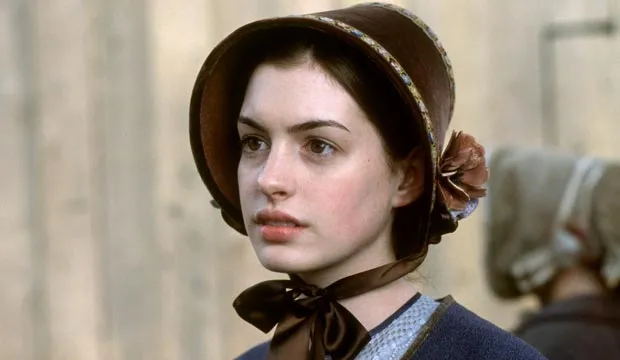What might this character be thinking about? This character could be pondering a multitude of things given her serious expression. She might be thinking about a lost love, reflecting on a pivotal moment in her life, or considering a difficult decision she has to make. The period costume suggests themes of duty, societal expectations, and possibly personal sacrifice. Describe a day in the life of this character. A day in the life of this character might start early in the morning with her preparing for the day's activities. Living in the Regency era, she would likely follow a structured routine, involving household management or social engagements. Her attire suggests she might be involved in significant family or social obligations, so her day could include meeting with friends or attending social events. Throughout the day, she engages in activities like reading, writing letters, or taking walks in the garden, all within the societal expectations of her time. Evening might bring more formal gatherings or quiet moments for contemplation, mirroring her serious expression in the image. 